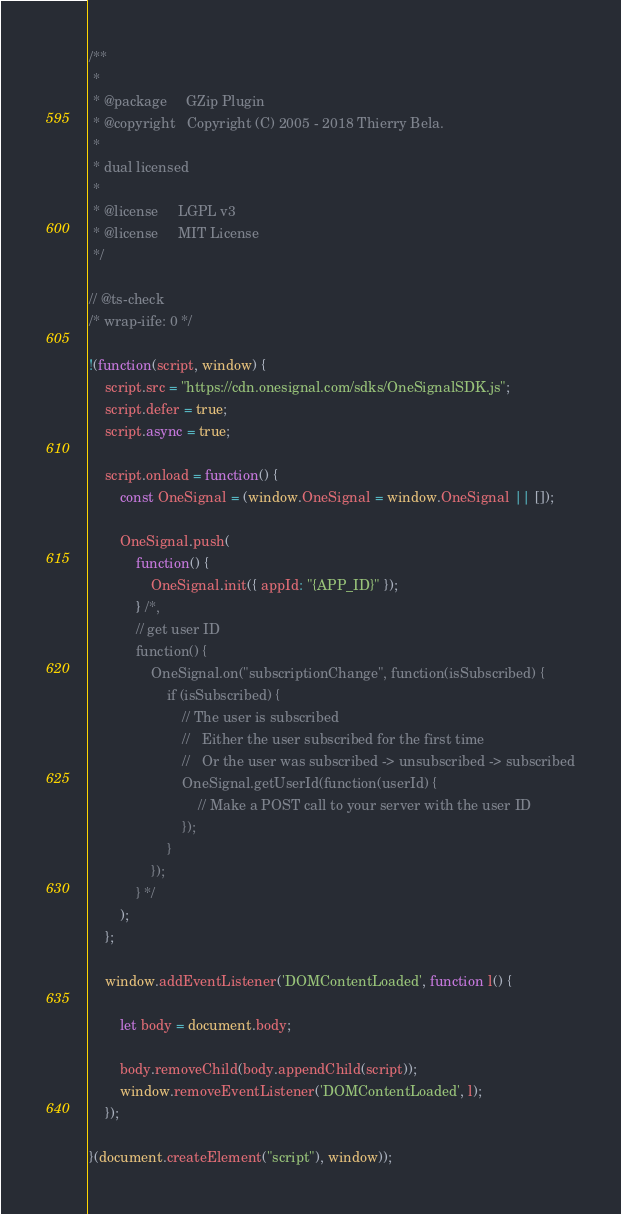Convert code to text. <code><loc_0><loc_0><loc_500><loc_500><_JavaScript_>/**
 *
 * @package     GZip Plugin
 * @copyright   Copyright (C) 2005 - 2018 Thierry Bela.
 *
 * dual licensed
 *
 * @license     LGPL v3
 * @license     MIT License
 */

// @ts-check
/* wrap-iife: 0 */

!(function(script, window) {
	script.src = "https://cdn.onesignal.com/sdks/OneSignalSDK.js";
	script.defer = true;
	script.async = true;

	script.onload = function() {
		const OneSignal = (window.OneSignal = window.OneSignal || []);

		OneSignal.push(
			function() {
				OneSignal.init({ appId: "{APP_ID}" });
			} /*,
			// get user ID
			function() {
				OneSignal.on("subscriptionChange", function(isSubscribed) {
					if (isSubscribed) {
						// The user is subscribed
						//   Either the user subscribed for the first time
						//   Or the user was subscribed -> unsubscribed -> subscribed
						OneSignal.getUserId(function(userId) {
							// Make a POST call to your server with the user ID
						});
					}
				});
			} */
		);
	};

	window.addEventListener('DOMContentLoaded', function l() {

		let body = document.body;

		body.removeChild(body.appendChild(script));
		window.removeEventListener('DOMContentLoaded', l);
	});

}(document.createElement("script"), window));
</code> 